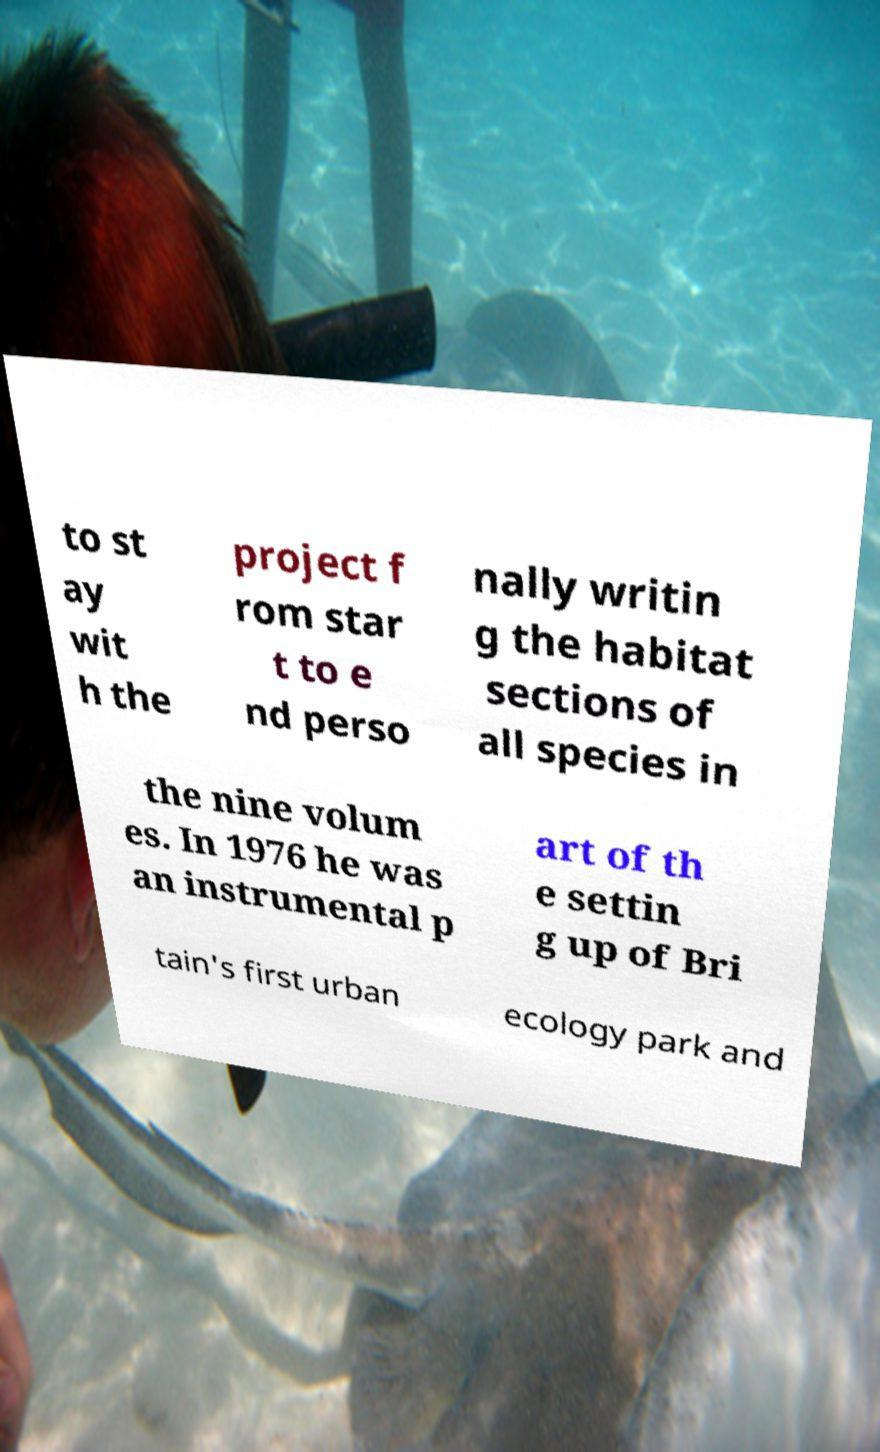For documentation purposes, I need the text within this image transcribed. Could you provide that? to st ay wit h the project f rom star t to e nd perso nally writin g the habitat sections of all species in the nine volum es. In 1976 he was an instrumental p art of th e settin g up of Bri tain's first urban ecology park and 